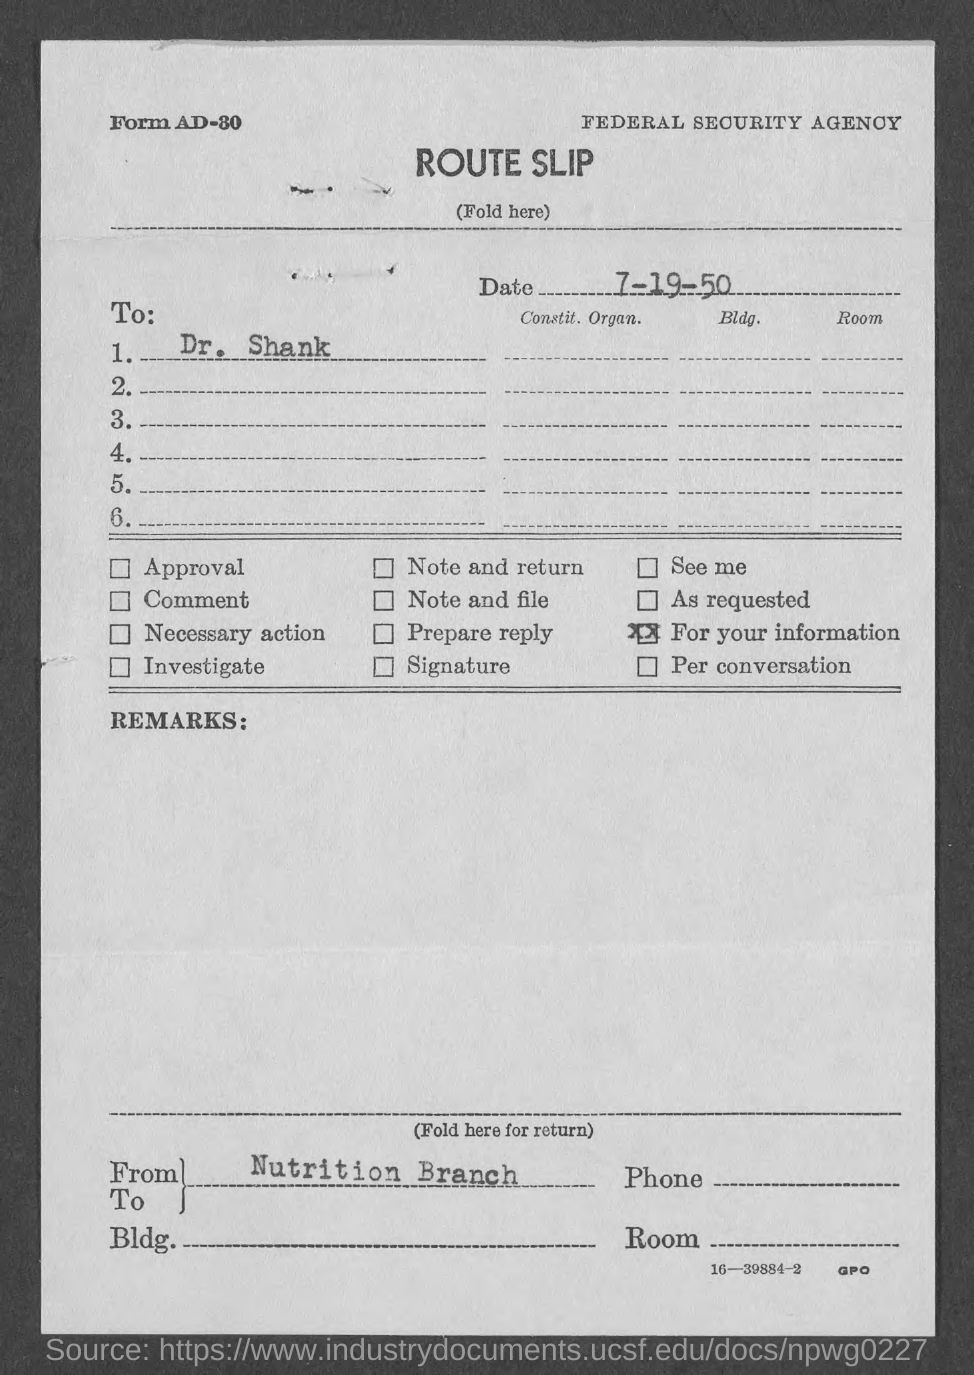What is the Date?
Keep it short and to the point. 7-19-50. To Whom is this letter addressed to?
Ensure brevity in your answer.  Dr. Shank. 